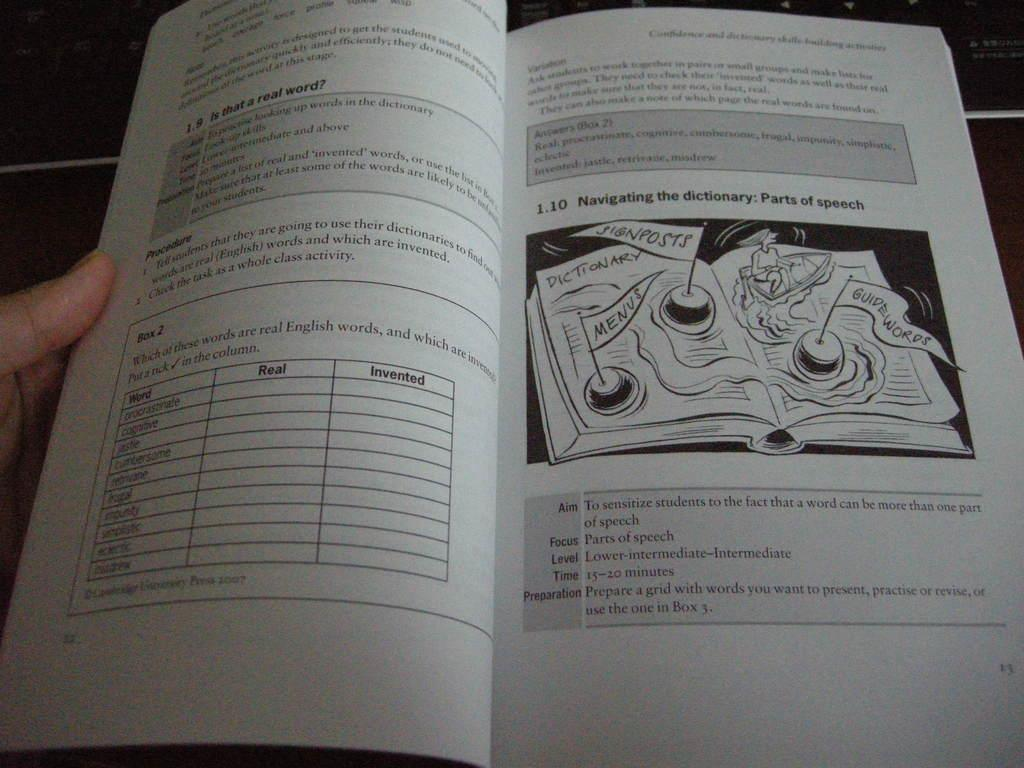<image>
Provide a brief description of the given image. A person looking at an open book about Parts of speech. 